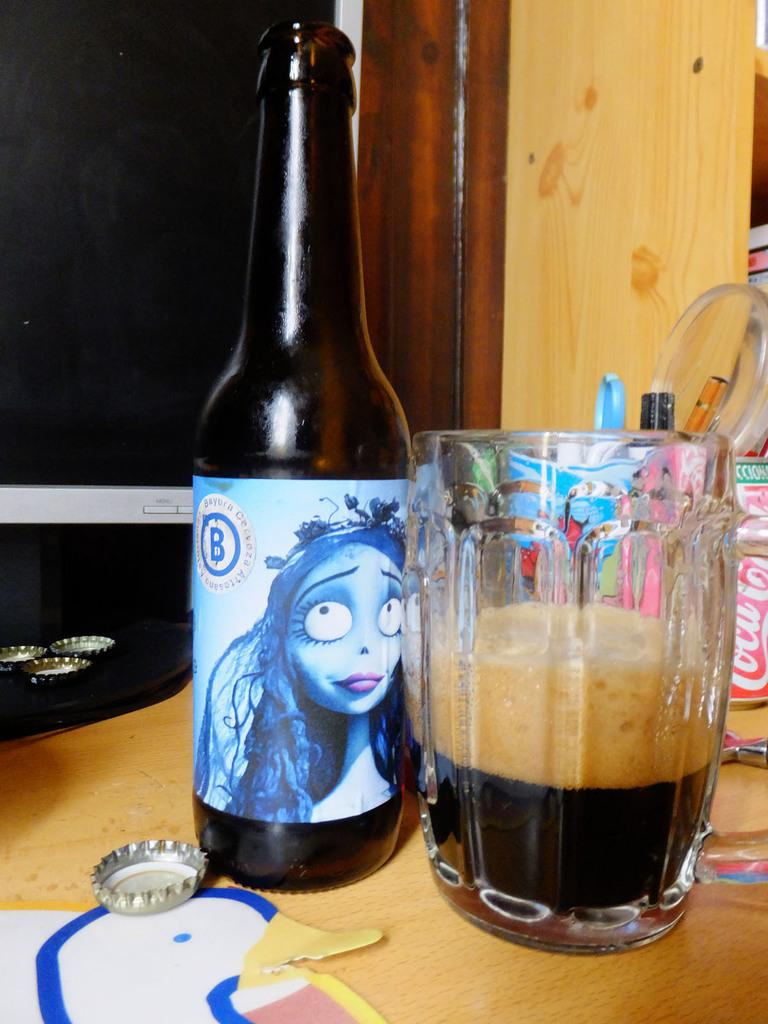<image>
Describe the image concisely. a bottle of bayura cerveza next to a partially filled glass of it 